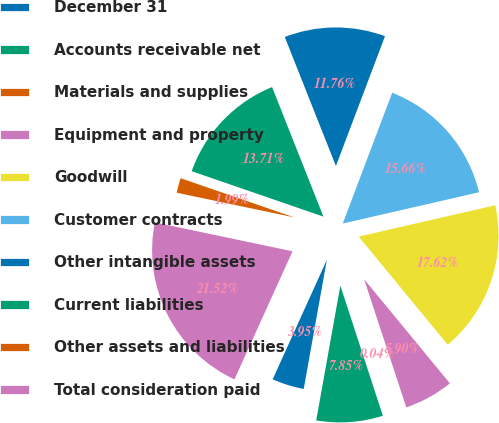Convert chart. <chart><loc_0><loc_0><loc_500><loc_500><pie_chart><fcel>December 31<fcel>Accounts receivable net<fcel>Materials and supplies<fcel>Equipment and property<fcel>Goodwill<fcel>Customer contracts<fcel>Other intangible assets<fcel>Current liabilities<fcel>Other assets and liabilities<fcel>Total consideration paid<nl><fcel>3.95%<fcel>7.85%<fcel>0.04%<fcel>5.9%<fcel>17.62%<fcel>15.66%<fcel>11.76%<fcel>13.71%<fcel>1.99%<fcel>21.52%<nl></chart> 